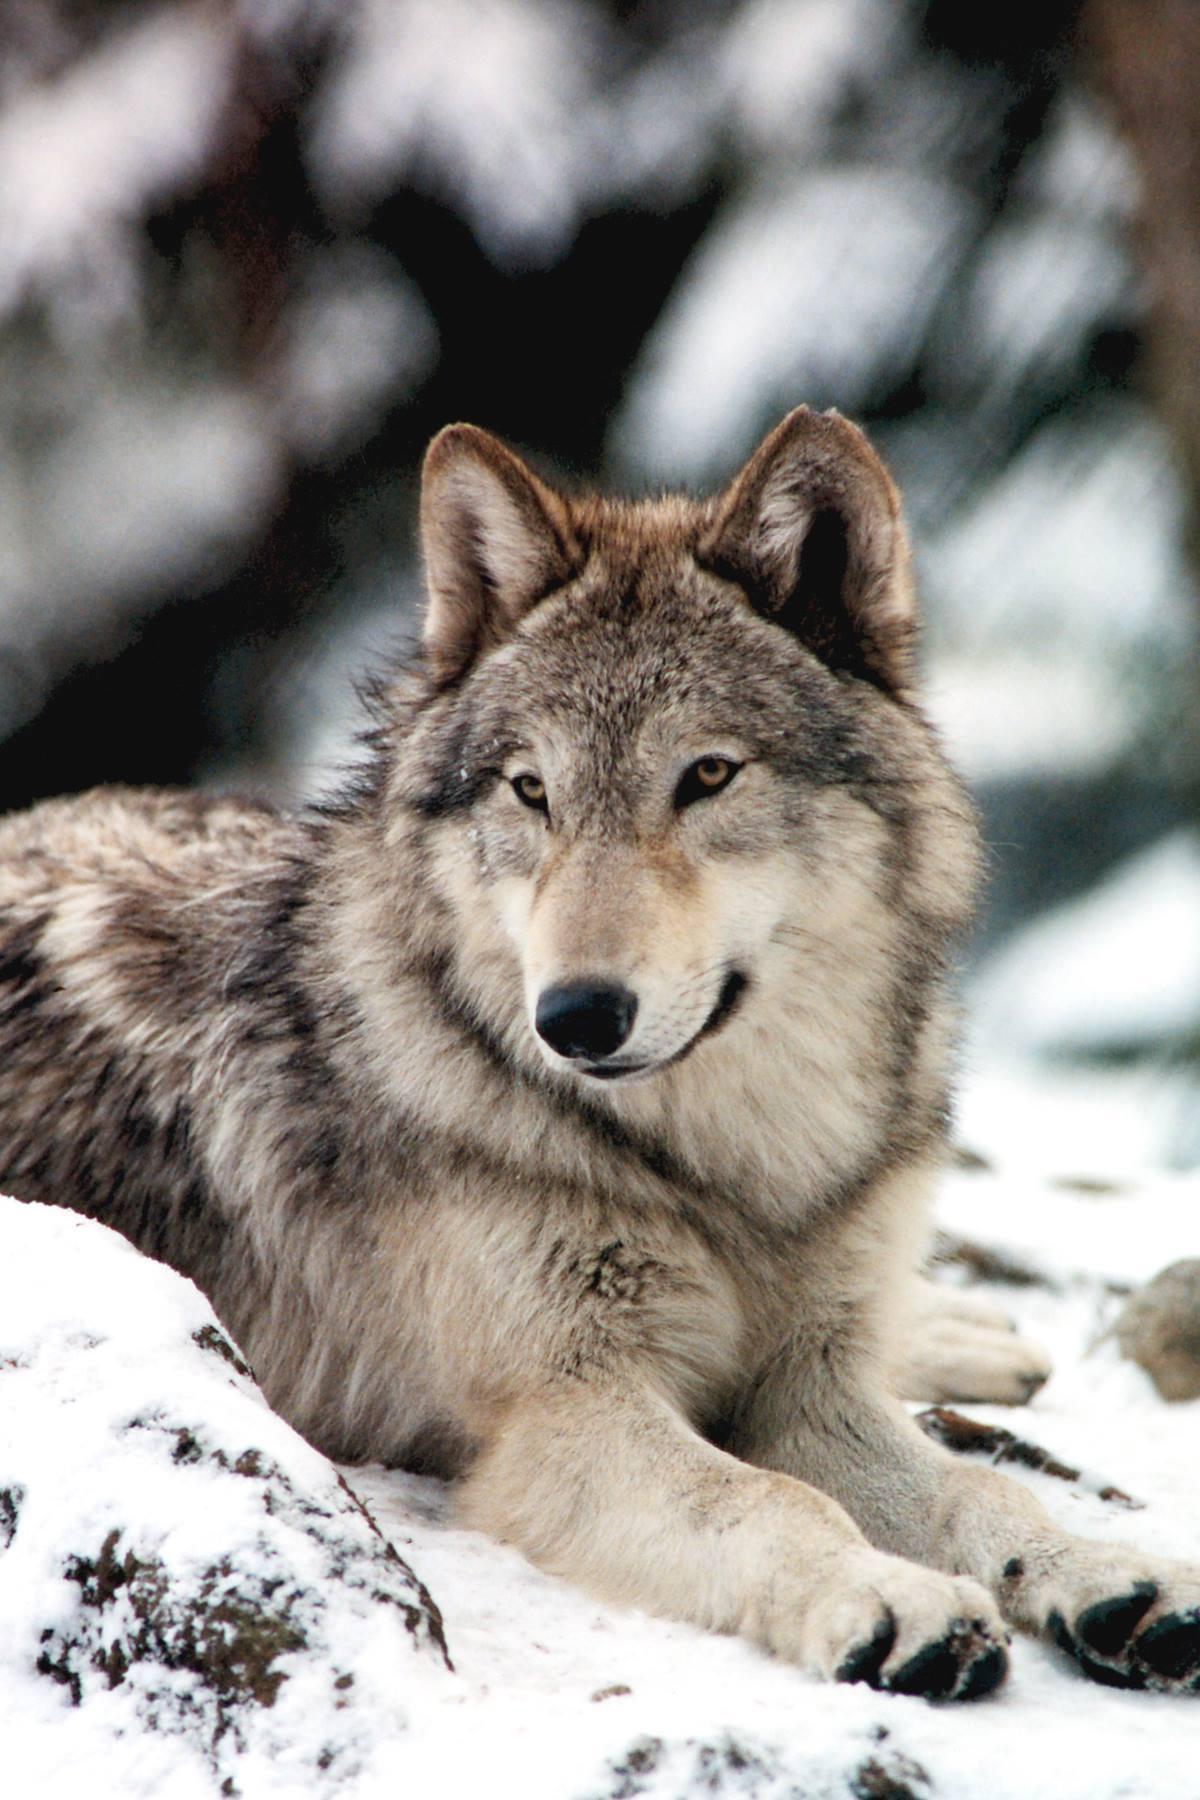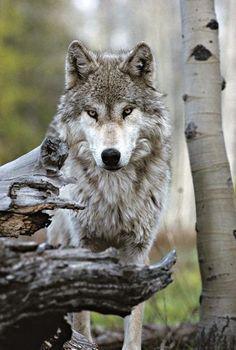The first image is the image on the left, the second image is the image on the right. Examine the images to the left and right. Is the description "The right image contains at least four wolves positioned close together in a snow-covered scene." accurate? Answer yes or no. No. The first image is the image on the left, the second image is the image on the right. For the images displayed, is the sentence "There are two wolves" factually correct? Answer yes or no. Yes. 